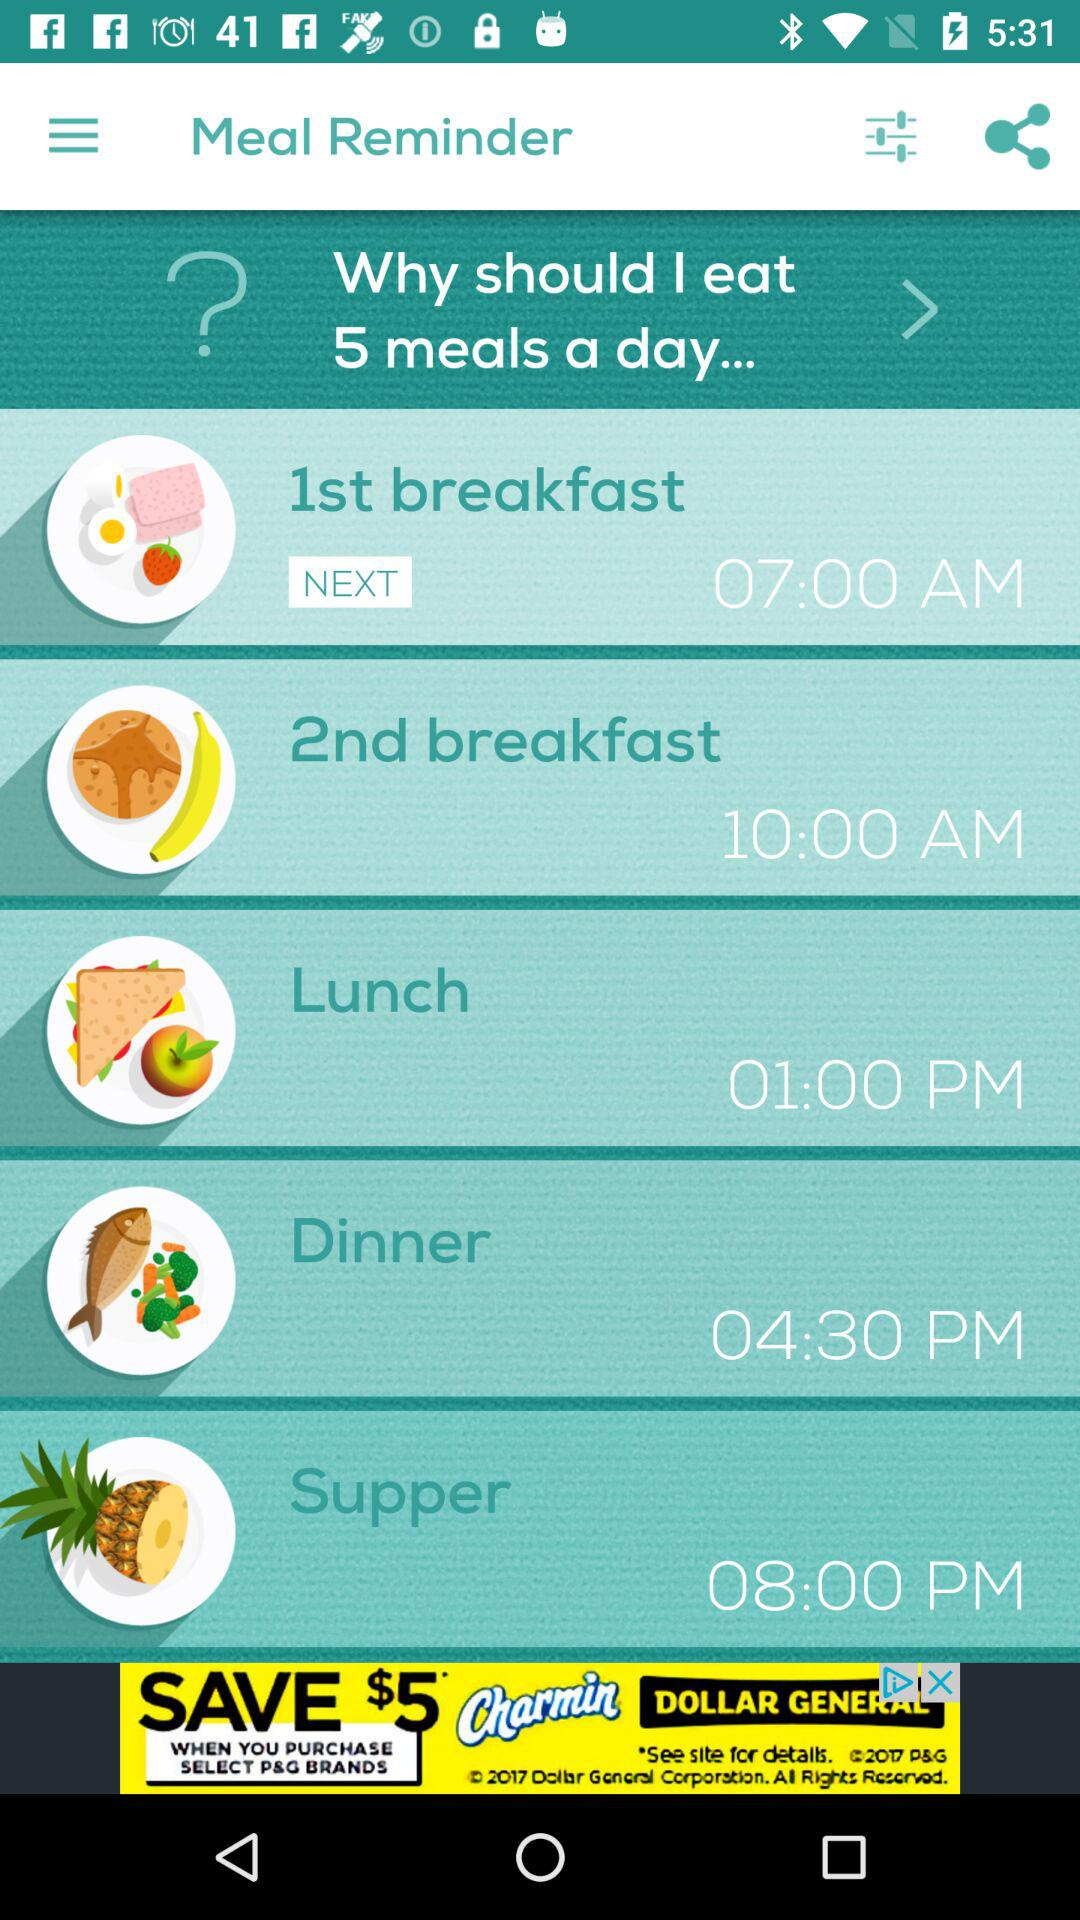What is the 2nd breakfast time? The 2nd breakfast time is 10:00 AM. 